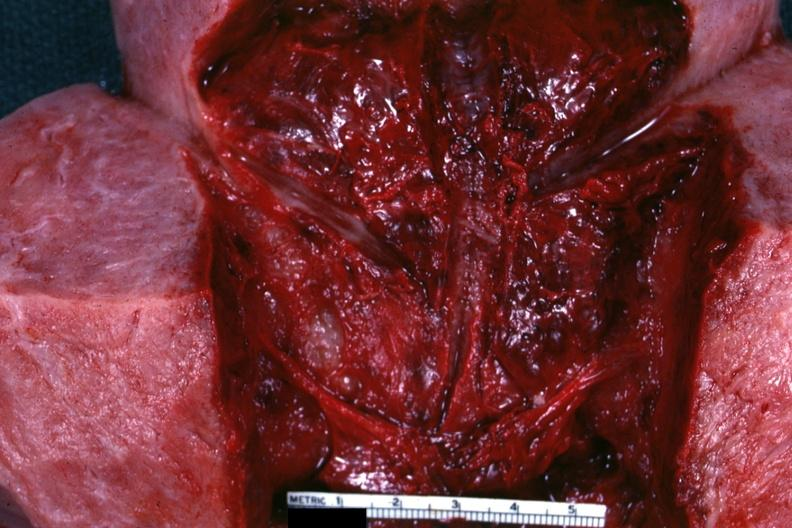s postpartum present?
Answer the question using a single word or phrase. Yes 